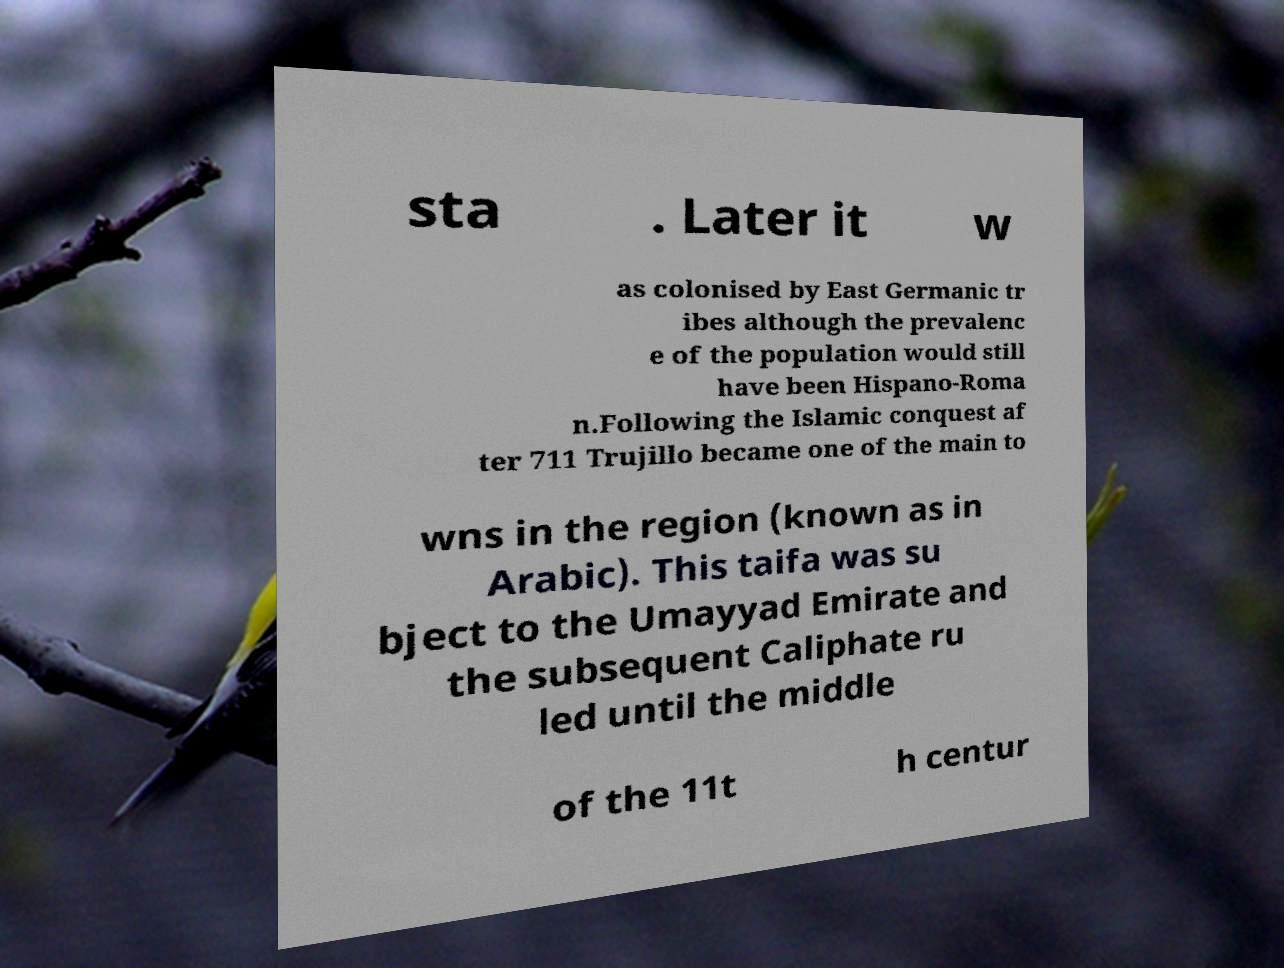What messages or text are displayed in this image? I need them in a readable, typed format. sta . Later it w as colonised by East Germanic tr ibes although the prevalenc e of the population would still have been Hispano-Roma n.Following the Islamic conquest af ter 711 Trujillo became one of the main to wns in the region (known as in Arabic). This taifa was su bject to the Umayyad Emirate and the subsequent Caliphate ru led until the middle of the 11t h centur 